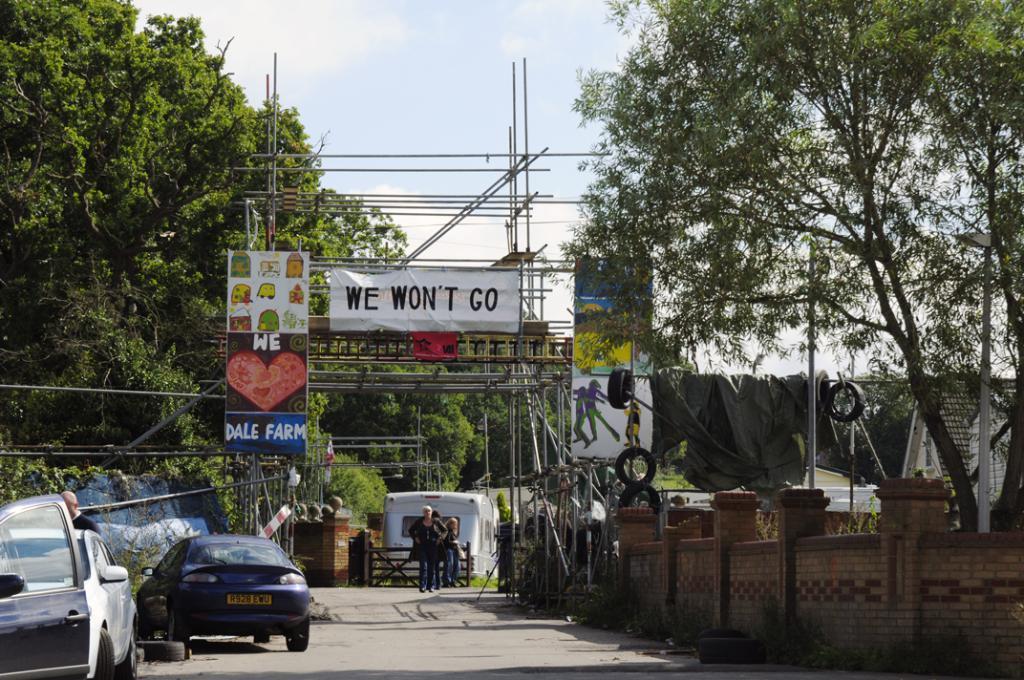In one or two sentences, can you explain what this image depicts? In the picture I can see the stainless steel scaffolding structure and there are banners on the structure. There are cars on the road on the bottom left side. I can see three persons on the road. I can see the brick wall on the right side. There are trees on the left side and the right side as well. There are clouds in the sky. 